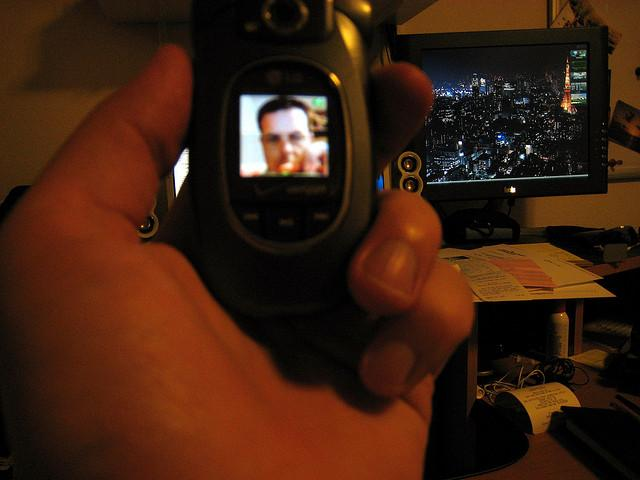What type of telephone does this person have?

Choices:
A) cellular
B) rotary
C) payphone
D) landline cellular 